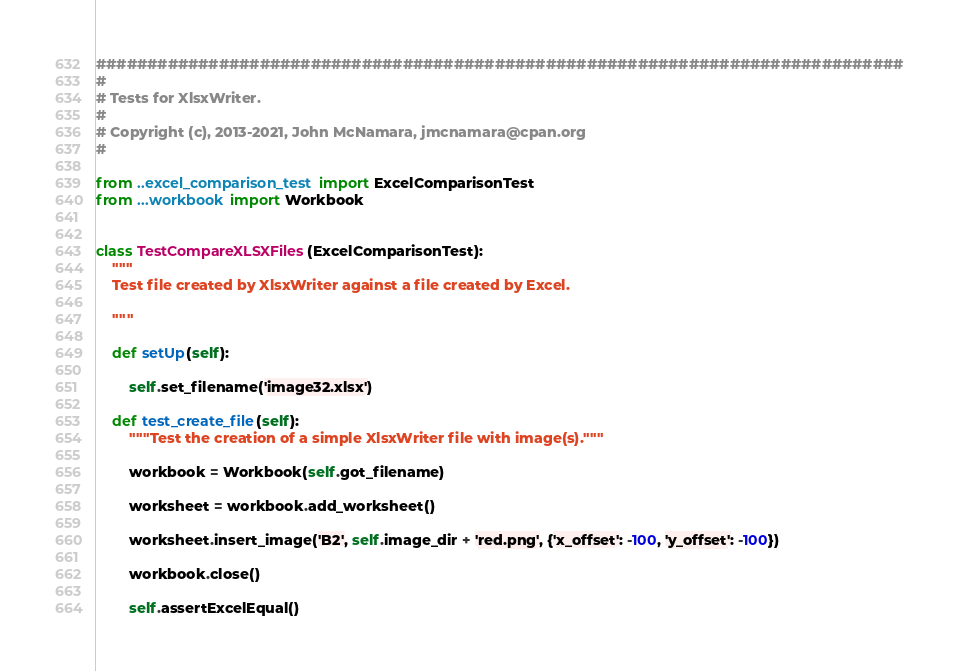Convert code to text. <code><loc_0><loc_0><loc_500><loc_500><_Python_>###############################################################################
#
# Tests for XlsxWriter.
#
# Copyright (c), 2013-2021, John McNamara, jmcnamara@cpan.org
#

from ..excel_comparison_test import ExcelComparisonTest
from ...workbook import Workbook


class TestCompareXLSXFiles(ExcelComparisonTest):
    """
    Test file created by XlsxWriter against a file created by Excel.

    """

    def setUp(self):

        self.set_filename('image32.xlsx')

    def test_create_file(self):
        """Test the creation of a simple XlsxWriter file with image(s)."""

        workbook = Workbook(self.got_filename)

        worksheet = workbook.add_worksheet()

        worksheet.insert_image('B2', self.image_dir + 'red.png', {'x_offset': -100, 'y_offset': -100})

        workbook.close()

        self.assertExcelEqual()
</code> 